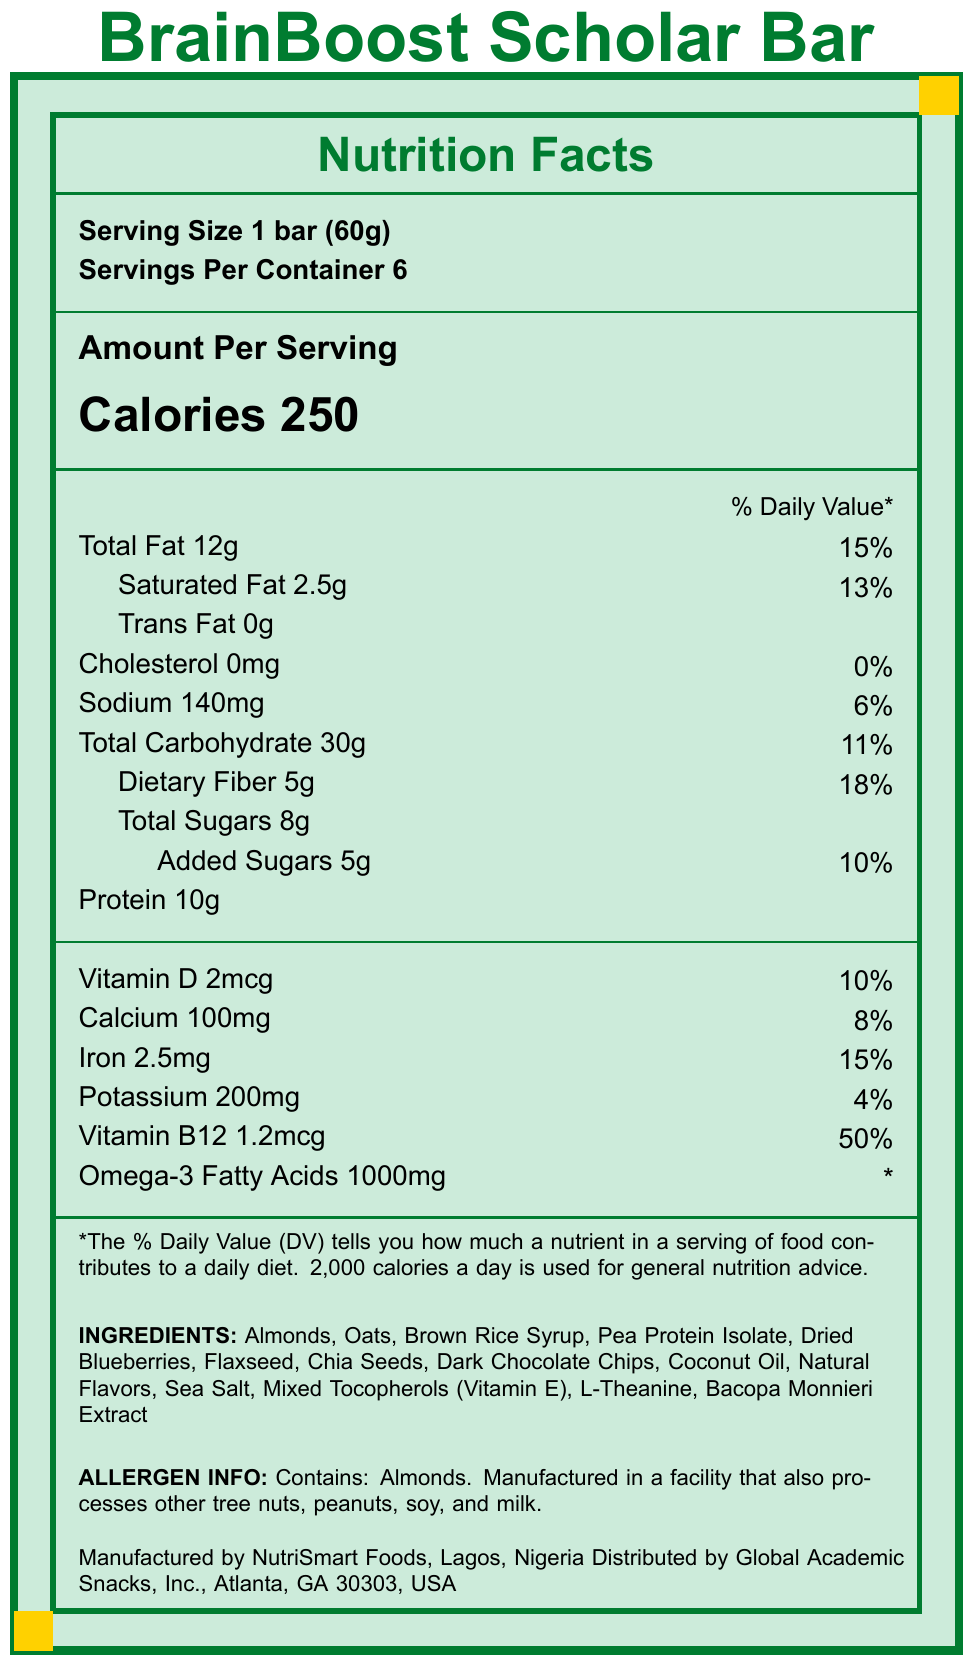what is the serving size for the BrainBoost Scholar Bar? The document specifies the serving size as "1 bar (60g)".
Answer: 1 bar (60g) how many calories are there per serving in the BrainBoost Scholar Bar? The document indicates that each serving contains 250 calories.
Answer: 250 what percentage of daily value is provided by the Omega-3 fatty acids in the BrainBoost Scholar Bar? The document mentions Omega-3 fatty acids at 1000mg but does not specify the percentage of daily value (\%DV).
Answer: Not specified how much protein is there in one serving of the BrainBoost Scholar Bar? The document states that there is 10g of protein per serving.
Answer: 10g what are some of the key ingredients in the BrainBoost Scholar Bar related to cognitive function and stress management? These ingredients are mentioned in the context of health claims for improving cognitive function and stress management.
Answer: L-Theanine, Bacopa Monnieri Extract, Omega-3 Fatty Acids which of the following vitamins and minerals are included in the BrainBoost Scholar Bar? A. Vitamin A B. Vitamin C C. Vitamin D D. Vitamin B6 Among the options, only Vitamin D is listed in the document.
Answer: C. Vitamin D how many servings are there in one container of BrainBoost Scholar Bar? A. 4 B. 6 C. 8 D. 10 The document mentions that there are 6 servings per container.
Answer: B. 6 Does the BrainBoost Scholar Bar contain any nuts? The document lists almonds as one of the ingredients and also mentions that it contains almonds.
Answer: Yes Is the BrainBoost Scholar Bar manufactured in the USA? The document states that the bar is manufactured by NutriSmart Foods in Lagos, Nigeria.
Answer: No Summarize the main idea of the document. The document provides detailed nutritional information, ingredients, health claims, and manufacturer and distributor details for the BrainBoost Scholar Bar.
Answer: The BrainBoost Scholar Bar is a nutrition bar designed to support academic performance and stress management. It contains 250 calories per serving and key ingredients such as protein, Omega-3 fatty acids, L-Theanine, and Bacopa Monnieri Extract to enhance cognitive function. It is manufactured in Nigeria and distributed in the USA. what is the source of protein in the BrainBoost Scholar Bar? The document mentions "Pea Protein Isolate" as an ingredient, but does not detail whether there are additional protein sources beyond that.
Answer: Not enough information 